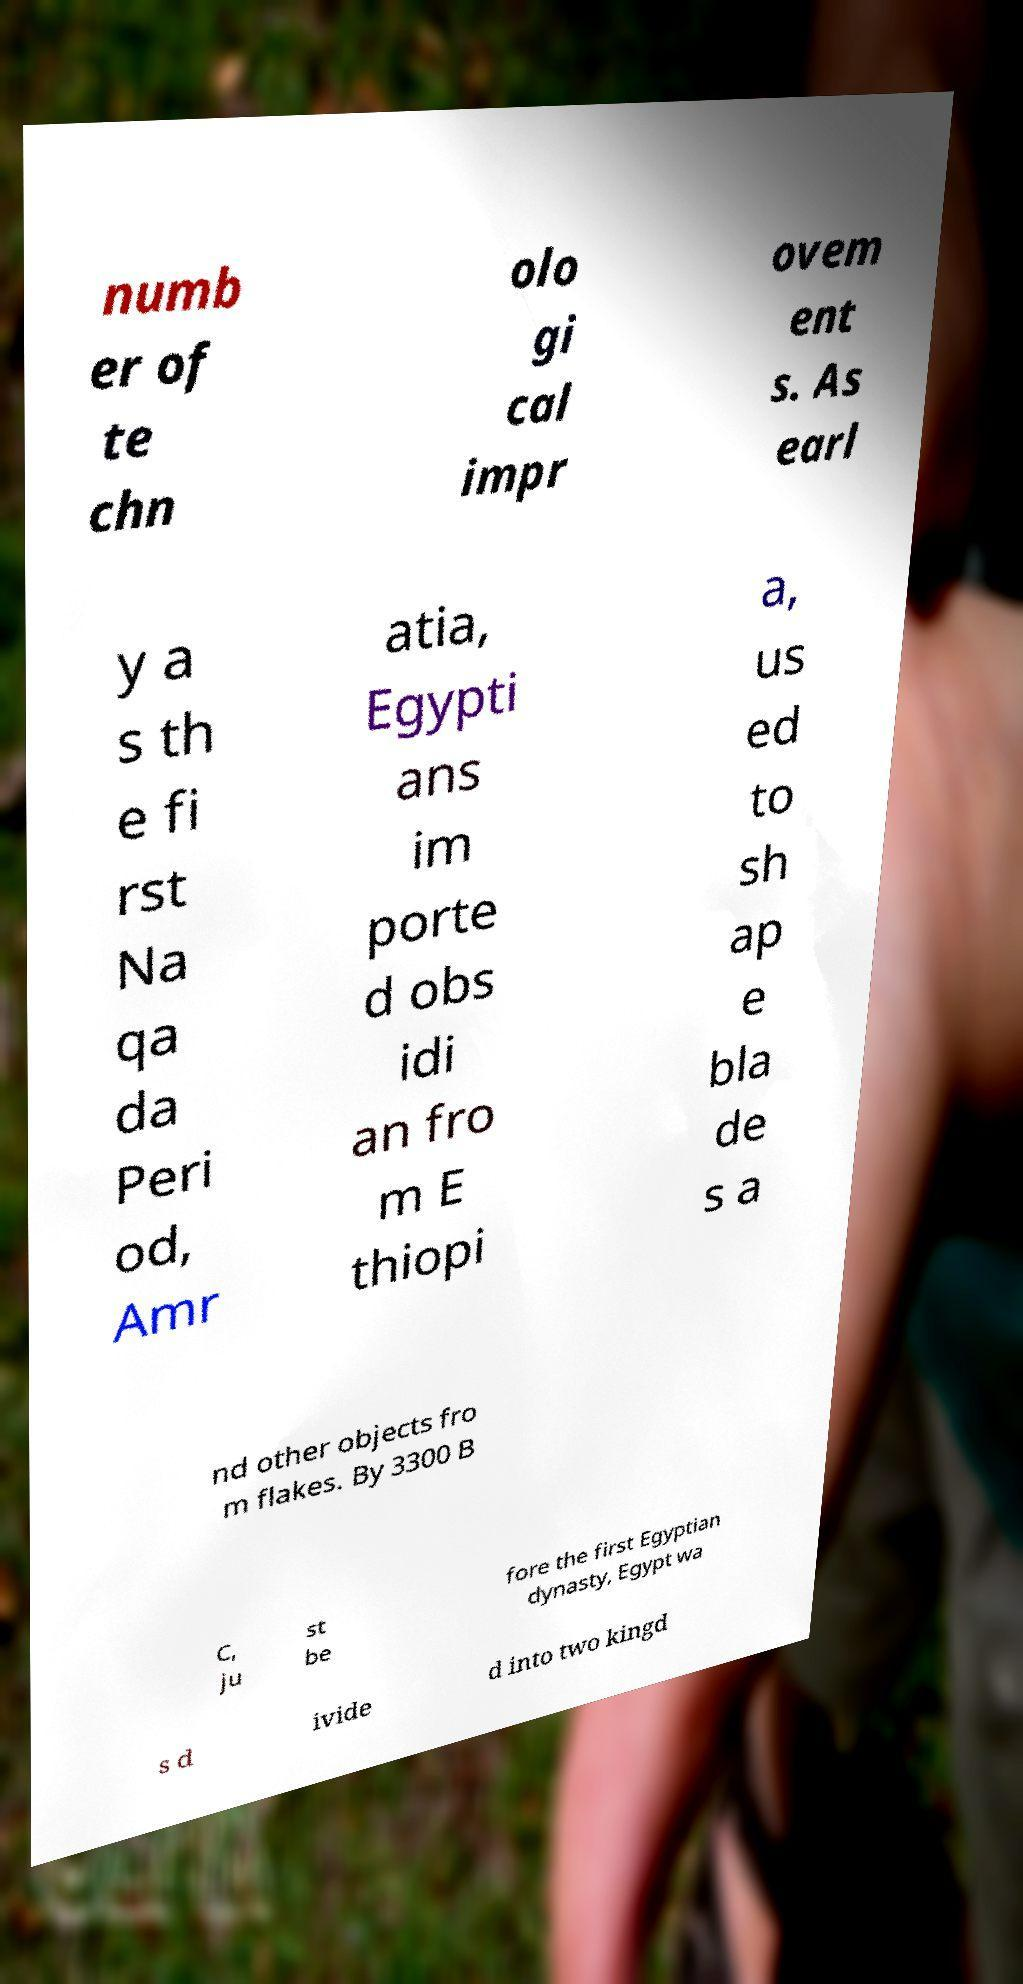There's text embedded in this image that I need extracted. Can you transcribe it verbatim? numb er of te chn olo gi cal impr ovem ent s. As earl y a s th e fi rst Na qa da Peri od, Amr atia, Egypti ans im porte d obs idi an fro m E thiopi a, us ed to sh ap e bla de s a nd other objects fro m flakes. By 3300 B C, ju st be fore the first Egyptian dynasty, Egypt wa s d ivide d into two kingd 